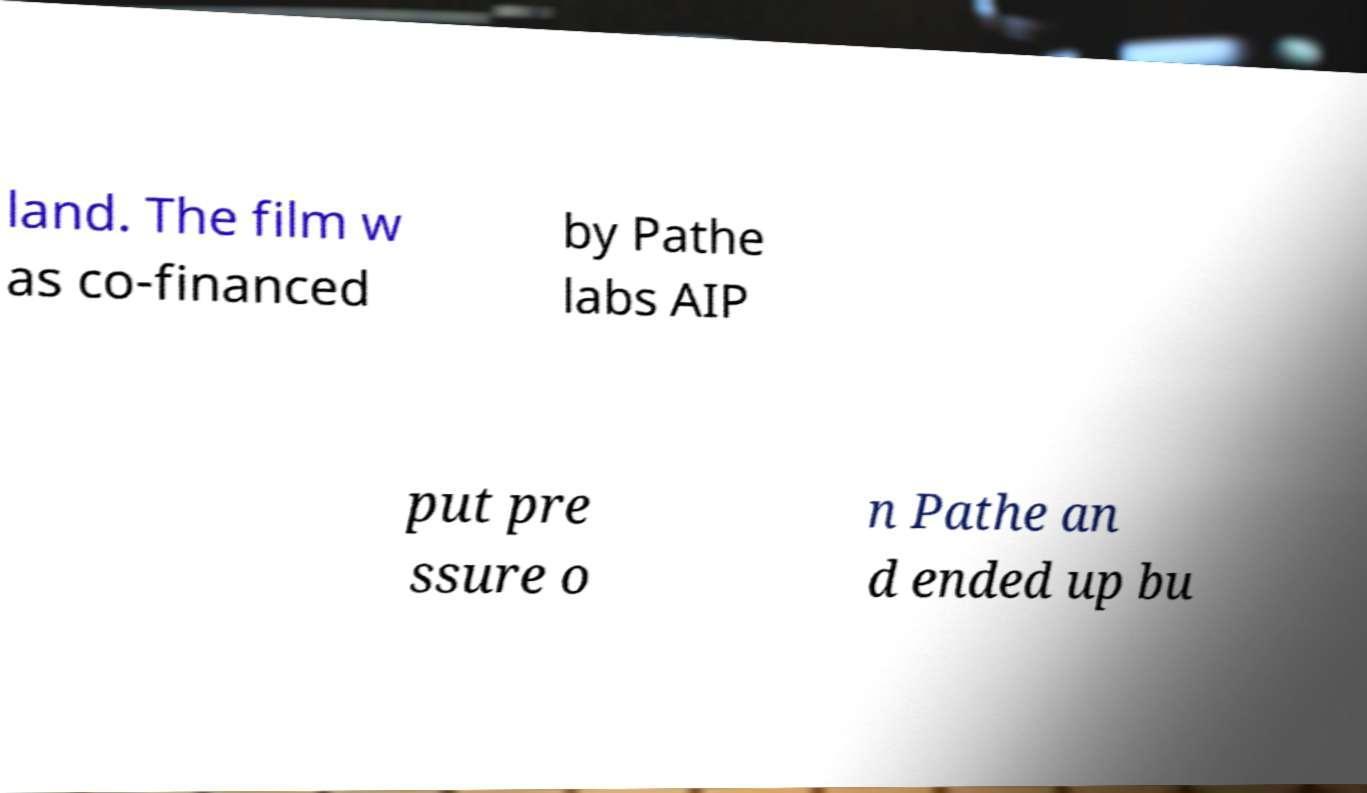Could you assist in decoding the text presented in this image and type it out clearly? land. The film w as co-financed by Pathe labs AIP put pre ssure o n Pathe an d ended up bu 